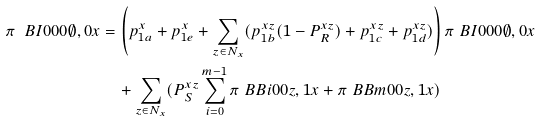<formula> <loc_0><loc_0><loc_500><loc_500>\pi \ B { I } { 0 } { 0 } { 0 } { \emptyset , 0 } { x } & = \left ( p ^ { x } _ { 1 a } + p ^ { x } _ { 1 e } + \sum _ { z \in N _ { x } } ( p ^ { x z } _ { 1 b } ( 1 - P ^ { x z } _ { R } ) + p ^ { x z } _ { 1 c } + p ^ { x z } _ { 1 d } ) \right ) \pi \ B { I } { 0 } { 0 } { 0 } { \emptyset , 0 } { x } \\ & \quad + \sum _ { z \in N _ { x } } ( P ^ { x z } _ { S } \sum _ { i = 0 } ^ { m - 1 } \pi \ B { B } { i } { 0 } { 0 } { z , 1 } { x } + \pi \ B { B } { m } { 0 } { 0 } { z , 1 } { x } )</formula> 